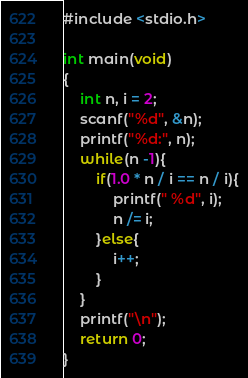Convert code to text. <code><loc_0><loc_0><loc_500><loc_500><_C#_>#include <stdio.h>

int main(void)
{
    int n, i = 2;
    scanf("%d", &n);
    printf("%d:", n);
    while(n -1){
        if(1.0 * n / i == n / i){
            printf(" %d", i);
            n /= i;
        }else{
            i++;
        }
    }
    printf("\n");
    return 0;
}
</code> 